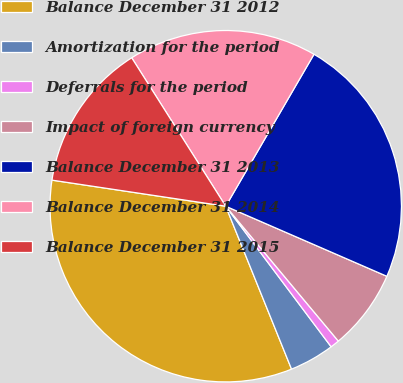Convert chart. <chart><loc_0><loc_0><loc_500><loc_500><pie_chart><fcel>Balance December 31 2012<fcel>Amortization for the period<fcel>Deferrals for the period<fcel>Impact of foreign currency<fcel>Balance December 31 2013<fcel>Balance December 31 2014<fcel>Balance December 31 2015<nl><fcel>33.48%<fcel>4.13%<fcel>0.83%<fcel>7.4%<fcel>23.15%<fcel>17.36%<fcel>13.64%<nl></chart> 